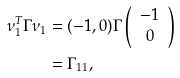<formula> <loc_0><loc_0><loc_500><loc_500>\nu _ { 1 } ^ { T } \Gamma \nu _ { 1 } & = ( - 1 , 0 ) \Gamma \left ( \begin{array} { c } - 1 \\ 0 \end{array} \right ) \\ & = \Gamma _ { 1 1 } ,</formula> 